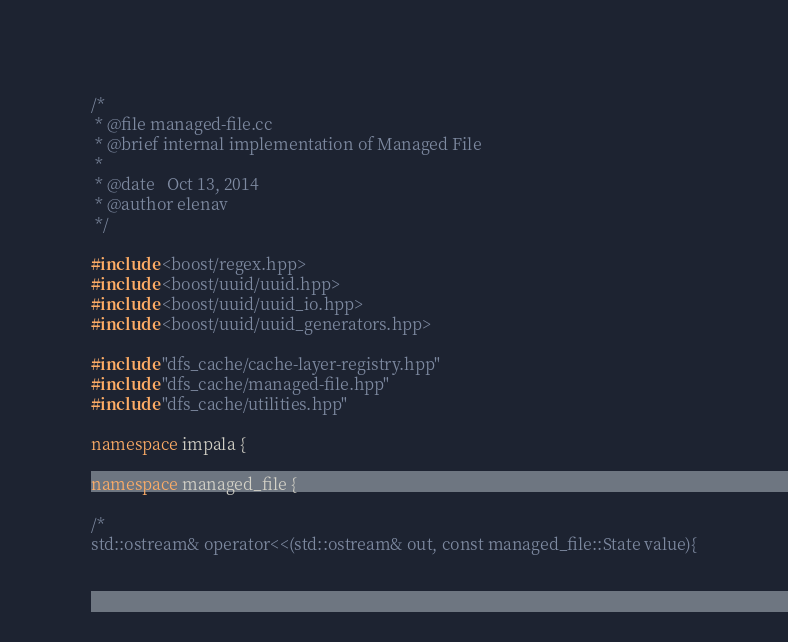Convert code to text. <code><loc_0><loc_0><loc_500><loc_500><_C++_>/*
 * @file managed-file.cc
 * @brief internal implementation of Managed File
 *
 * @date   Oct 13, 2014
 * @author elenav
 */

#include <boost/regex.hpp>
#include <boost/uuid/uuid.hpp>
#include <boost/uuid/uuid_io.hpp>
#include <boost/uuid/uuid_generators.hpp>

#include "dfs_cache/cache-layer-registry.hpp"
#include "dfs_cache/managed-file.hpp"
#include "dfs_cache/utilities.hpp"

namespace impala {

namespace managed_file {

/*
std::ostream& operator<<(std::ostream& out, const managed_file::State value){</code> 